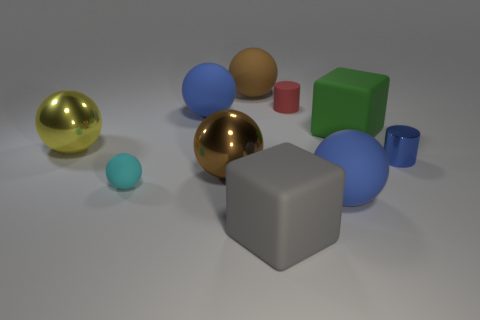Are there the same number of big green things behind the big brown matte ball and blue cylinders?
Your answer should be compact. No. How many metallic spheres have the same size as the gray matte cube?
Your response must be concise. 2. Is there a tiny green rubber object?
Make the answer very short. No. Is the shape of the big brown object that is in front of the big yellow shiny sphere the same as the blue rubber thing that is in front of the large yellow metallic ball?
Offer a terse response. Yes. How many small objects are either blocks or red rubber balls?
Ensure brevity in your answer.  0. There is a red object that is the same material as the green cube; what shape is it?
Keep it short and to the point. Cylinder. Is the big green rubber object the same shape as the cyan matte object?
Provide a succinct answer. No. What color is the small ball?
Give a very brief answer. Cyan. How many objects are either blue shiny spheres or metallic balls?
Offer a very short reply. 2. Are there any other things that are made of the same material as the small red object?
Your response must be concise. Yes. 